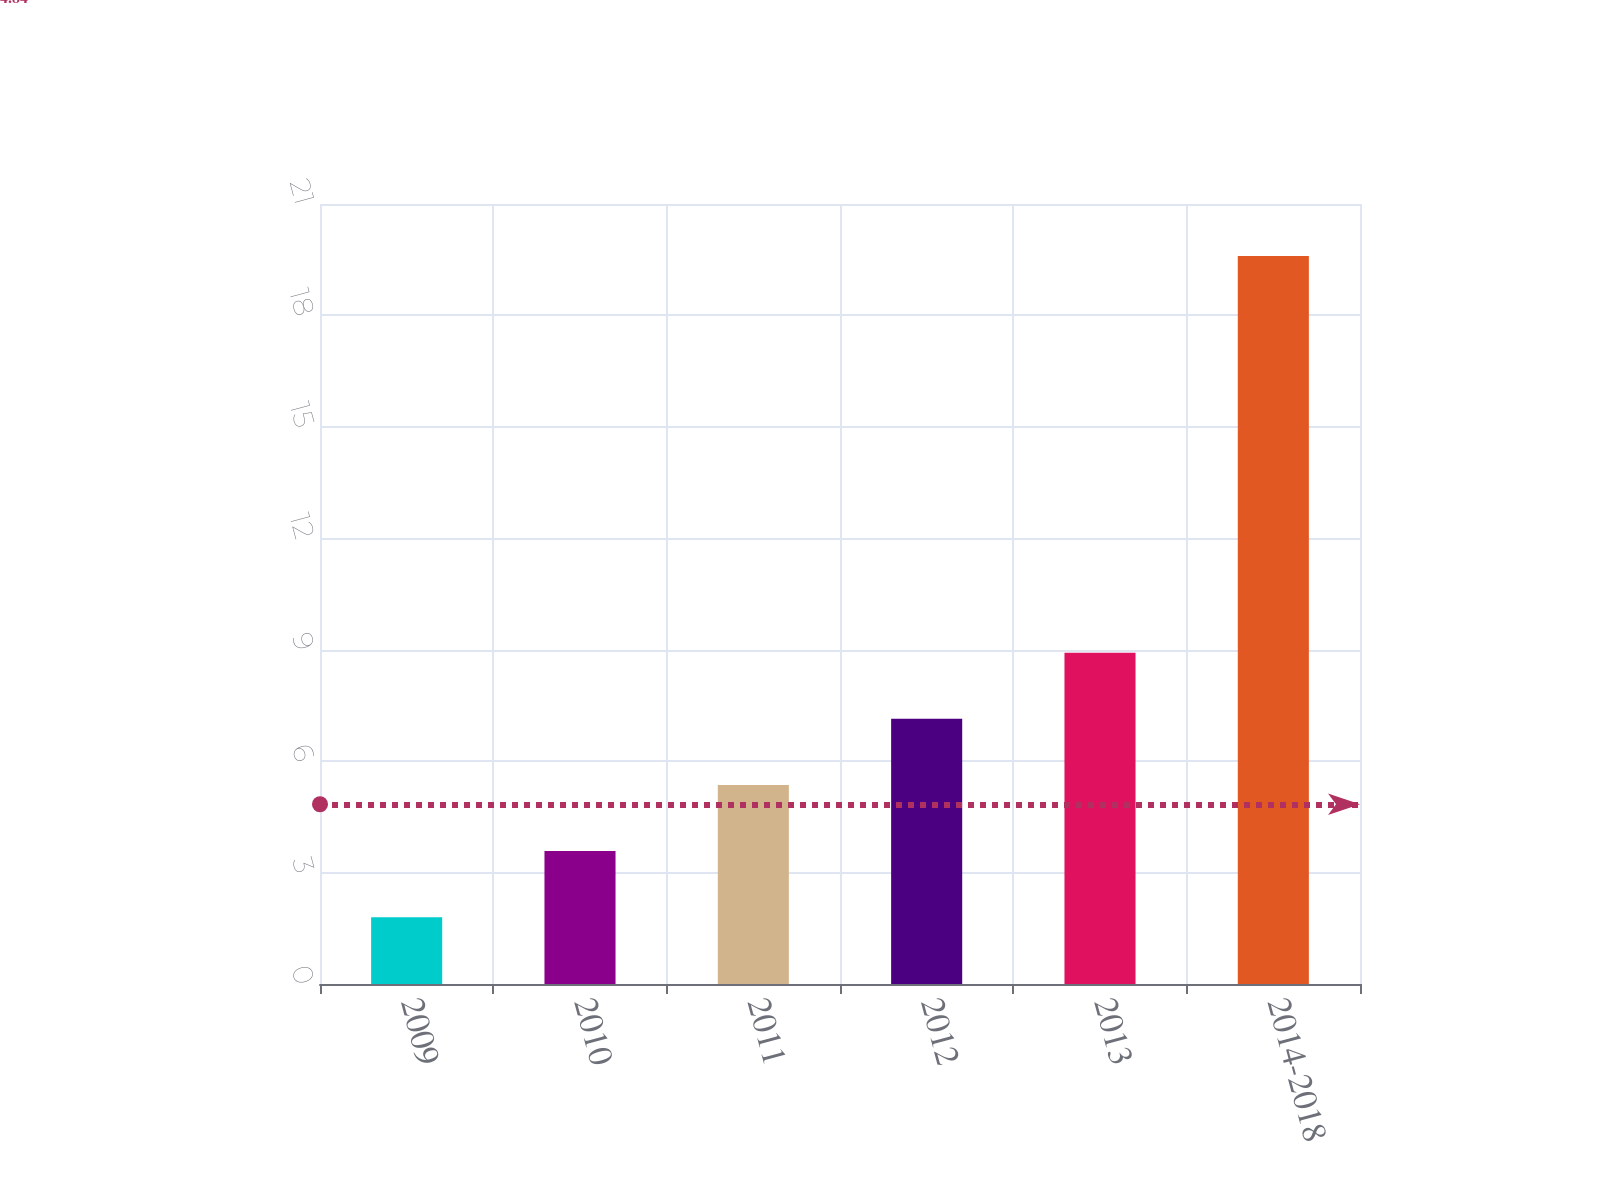<chart> <loc_0><loc_0><loc_500><loc_500><bar_chart><fcel>2009<fcel>2010<fcel>2011<fcel>2012<fcel>2013<fcel>2014-2018<nl><fcel>1.8<fcel>3.58<fcel>5.36<fcel>7.14<fcel>8.92<fcel>19.6<nl></chart> 